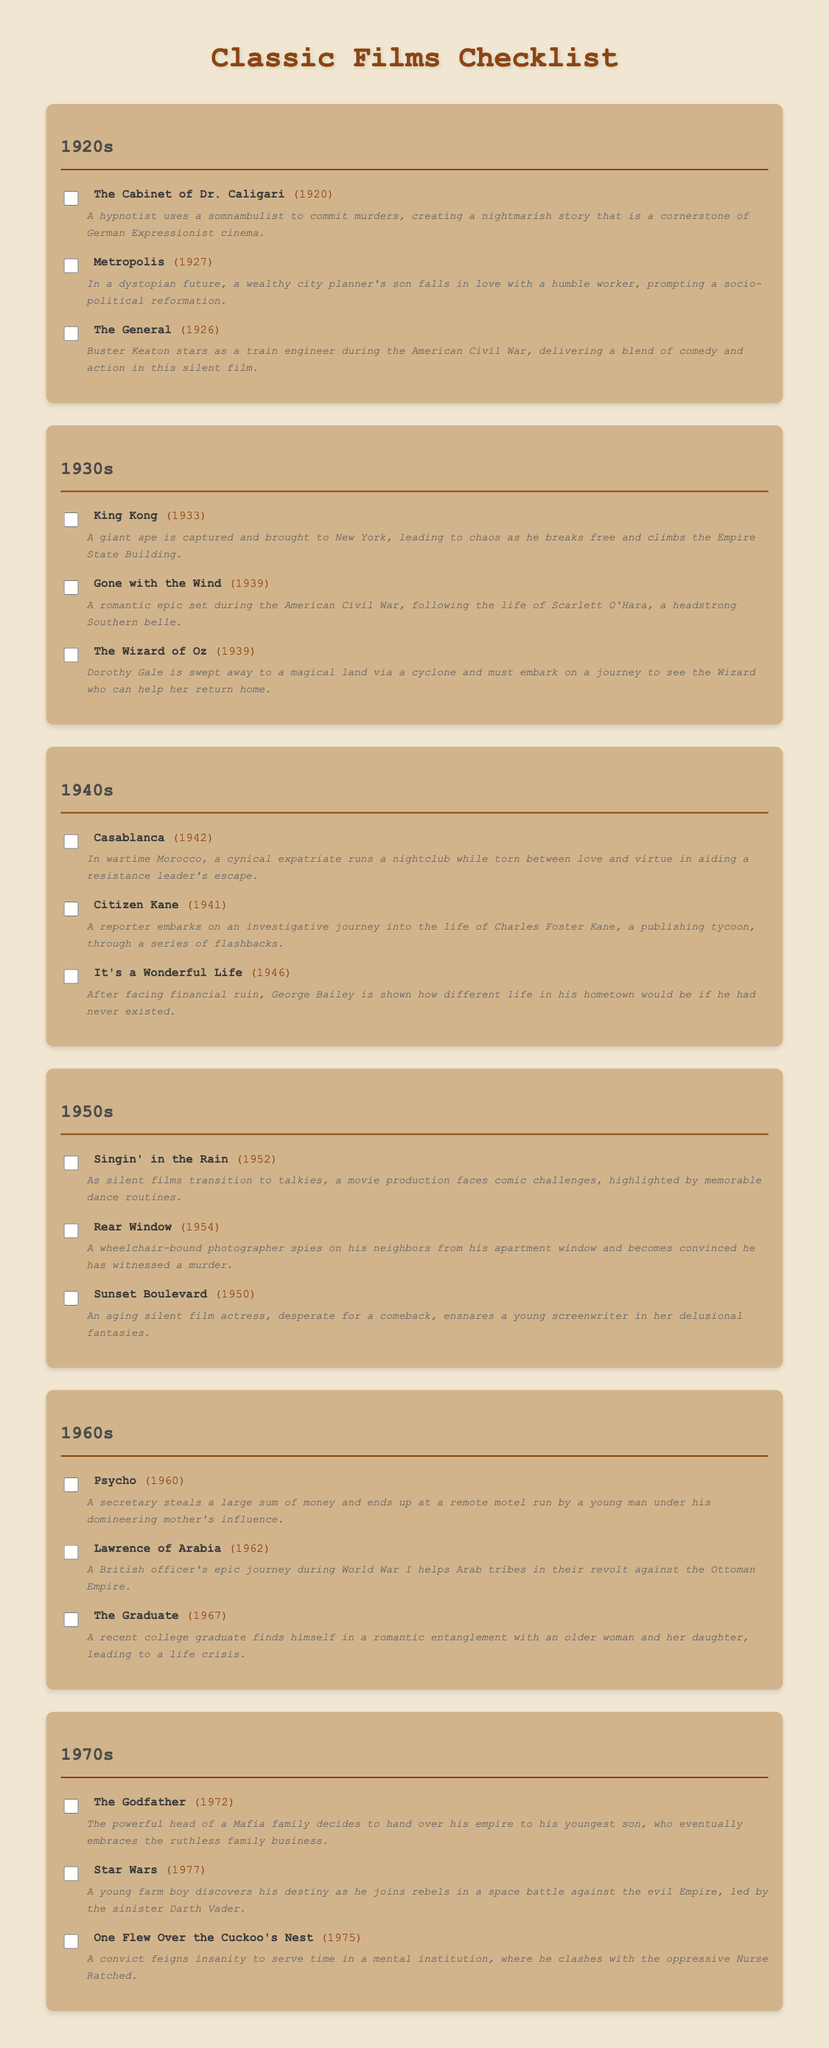What film was released in 1920? The film listed under the 1920s decade is "The Cabinet of Dr. Caligari."
Answer: The Cabinet of Dr. Caligari Which 1939 film features a magical journey to meet a wizard? The film that fits this description is "The Wizard of Oz."
Answer: The Wizard of Oz How many films are listed from the 1950s? There are three films listed under the decade of the 1950s in the document.
Answer: 3 What year was "Psycho" released? The document specifies that "Psycho" was released in the year 1960.
Answer: 1960 Which film from the 1940s focuses on a cynical expatriate in wartime Morocco? That film is "Casablanca."
Answer: Casablanca What is the title of the 1972 film about a powerful Mafia family? The film is titled "The Godfather."
Answer: The Godfather Which film features a giant ape and was released in 1933? The film is "King Kong."
Answer: King Kong What common theme is present in both "It's a Wonderful Life" and "Citizen Kane"? Both films explore the concept of life and its significance, but "It's a Wonderful Life" showcases a man's impact on community while "Citizen Kane" reflects on the solitary life of an influential tycoon.
Answer: Life significance What decade does "Rear Window" belong to? The film "Rear Window" is categorized under the 1950s.
Answer: 1950s 